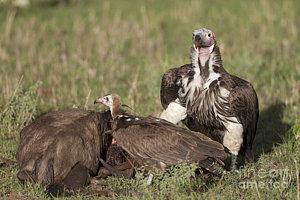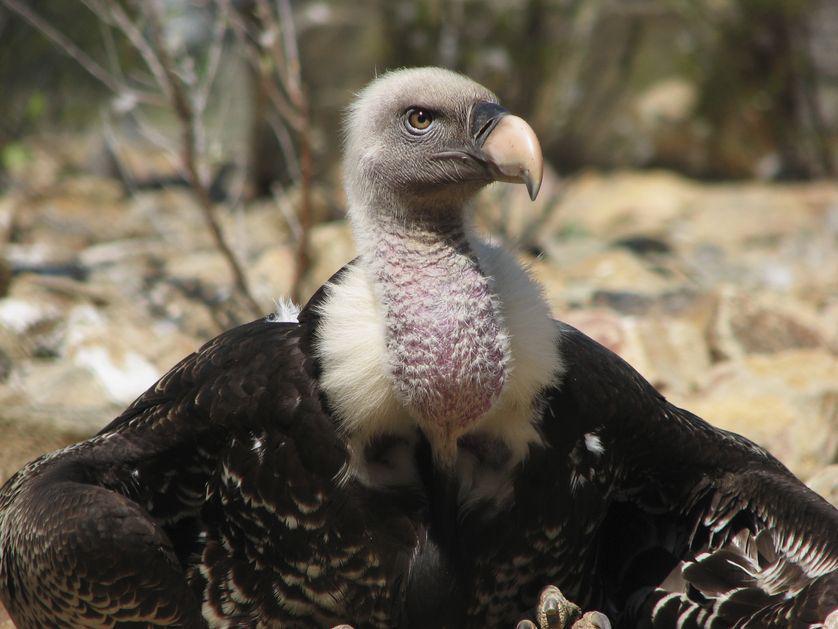The first image is the image on the left, the second image is the image on the right. Considering the images on both sides, is "There are more than four birds." valid? Answer yes or no. No. The first image is the image on the left, the second image is the image on the right. For the images shown, is this caption "An image shows exactly two side-by-side vultures posed with no space between them." true? Answer yes or no. No. 